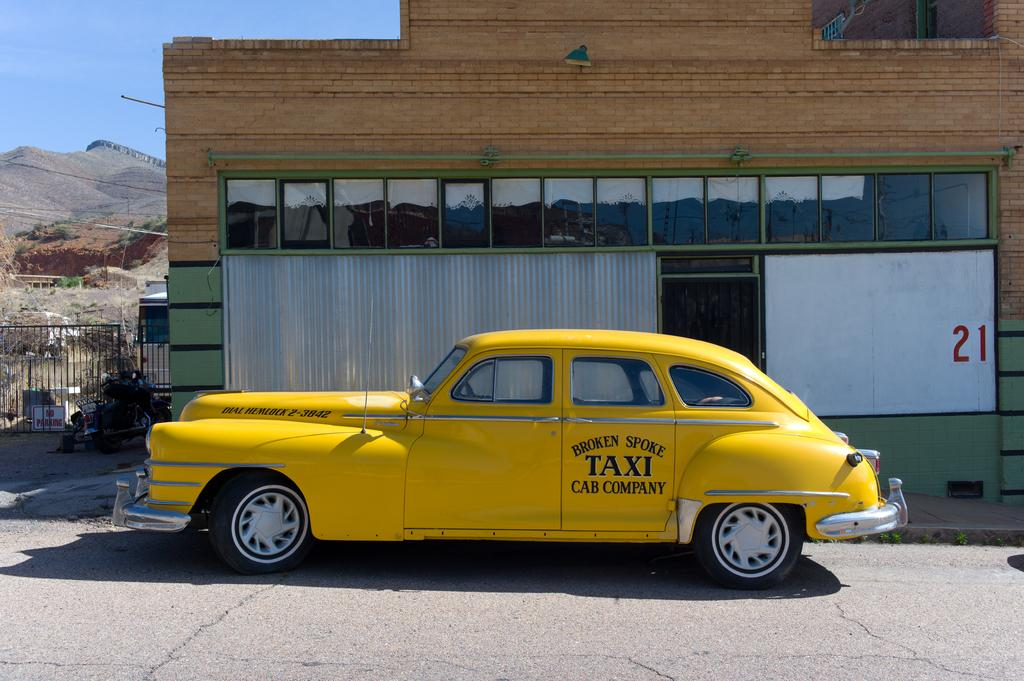<image>
Relay a brief, clear account of the picture shown. The old fashioned taxi is on display for people. 